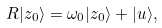<formula> <loc_0><loc_0><loc_500><loc_500>R | z _ { 0 } \rangle = \omega _ { 0 } | z _ { 0 } \rangle + | u \rangle ,</formula> 